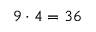<formula> <loc_0><loc_0><loc_500><loc_500>9 \cdot 4 = 3 6</formula> 